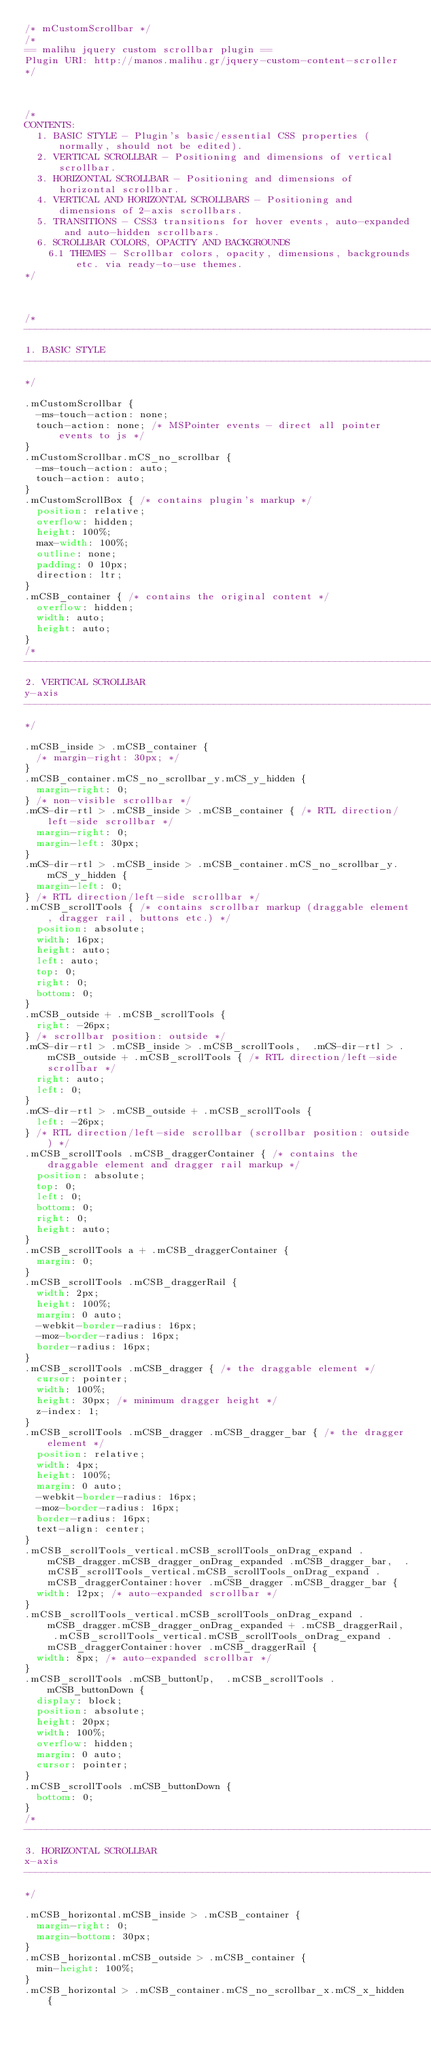Convert code to text. <code><loc_0><loc_0><loc_500><loc_500><_CSS_>/* mCustomScrollbar */
/*
== malihu jquery custom scrollbar plugin ==
Plugin URI: http://manos.malihu.gr/jquery-custom-content-scroller
*/



/*
CONTENTS: 
	1. BASIC STYLE - Plugin's basic/essential CSS properties (normally, should not be edited). 
	2. VERTICAL SCROLLBAR - Positioning and dimensions of vertical scrollbar. 
	3. HORIZONTAL SCROLLBAR - Positioning and dimensions of horizontal scrollbar.
	4. VERTICAL AND HORIZONTAL SCROLLBARS - Positioning and dimensions of 2-axis scrollbars. 
	5. TRANSITIONS - CSS3 transitions for hover events, auto-expanded and auto-hidden scrollbars. 
	6. SCROLLBAR COLORS, OPACITY AND BACKGROUNDS 
		6.1 THEMES - Scrollbar colors, opacity, dimensions, backgrounds etc. via ready-to-use themes.
*/



/* 
------------------------------------------------------------------------------------------------------------------------
1. BASIC STYLE  
------------------------------------------------------------------------------------------------------------------------
*/

.mCustomScrollbar {
	-ms-touch-action: none;
	touch-action: none; /* MSPointer events - direct all pointer events to js */
}
.mCustomScrollbar.mCS_no_scrollbar {
	-ms-touch-action: auto;
	touch-action: auto;
}
.mCustomScrollBox { /* contains plugin's markup */
	position: relative;
	overflow: hidden;
	height: 100%;
	max-width: 100%;
	outline: none;
	padding: 0 10px;
	direction: ltr;
}
.mCSB_container { /* contains the original content */
	overflow: hidden;
	width: auto;
	height: auto;
}
/* 
------------------------------------------------------------------------------------------------------------------------
2. VERTICAL SCROLLBAR 
y-axis
------------------------------------------------------------------------------------------------------------------------
*/

.mCSB_inside > .mCSB_container {
	/* margin-right: 30px; */
}
.mCSB_container.mCS_no_scrollbar_y.mCS_y_hidden {
	margin-right: 0;
} /* non-visible scrollbar */
.mCS-dir-rtl > .mCSB_inside > .mCSB_container { /* RTL direction/left-side scrollbar */
	margin-right: 0;
	margin-left: 30px;
}
.mCS-dir-rtl > .mCSB_inside > .mCSB_container.mCS_no_scrollbar_y.mCS_y_hidden {
	margin-left: 0;
} /* RTL direction/left-side scrollbar */
.mCSB_scrollTools { /* contains scrollbar markup (draggable element, dragger rail, buttons etc.) */
	position: absolute;
	width: 16px;
	height: auto;
	left: auto;
	top: 0;
	right: 0;
	bottom: 0;
}
.mCSB_outside + .mCSB_scrollTools {
	right: -26px;
} /* scrollbar position: outside */
.mCS-dir-rtl > .mCSB_inside > .mCSB_scrollTools,  .mCS-dir-rtl > .mCSB_outside + .mCSB_scrollTools { /* RTL direction/left-side scrollbar */
	right: auto;
	left: 0;
}
.mCS-dir-rtl > .mCSB_outside + .mCSB_scrollTools {
	left: -26px;
} /* RTL direction/left-side scrollbar (scrollbar position: outside) */
.mCSB_scrollTools .mCSB_draggerContainer { /* contains the draggable element and dragger rail markup */
	position: absolute;
	top: 0;
	left: 0;
	bottom: 0;
	right: 0;
	height: auto;
}
.mCSB_scrollTools a + .mCSB_draggerContainer {
	margin: 0;
}
.mCSB_scrollTools .mCSB_draggerRail {
	width: 2px;
	height: 100%;
	margin: 0 auto;
	-webkit-border-radius: 16px;
	-moz-border-radius: 16px;
	border-radius: 16px;
}
.mCSB_scrollTools .mCSB_dragger { /* the draggable element */
	cursor: pointer;
	width: 100%;
	height: 30px; /* minimum dragger height */
	z-index: 1;
}
.mCSB_scrollTools .mCSB_dragger .mCSB_dragger_bar { /* the dragger element */
	position: relative;
	width: 4px;
	height: 100%;
	margin: 0 auto;
	-webkit-border-radius: 16px;
	-moz-border-radius: 16px;
	border-radius: 16px;
	text-align: center;
}
.mCSB_scrollTools_vertical.mCSB_scrollTools_onDrag_expand .mCSB_dragger.mCSB_dragger_onDrag_expanded .mCSB_dragger_bar,  .mCSB_scrollTools_vertical.mCSB_scrollTools_onDrag_expand .mCSB_draggerContainer:hover .mCSB_dragger .mCSB_dragger_bar {
	width: 12px; /* auto-expanded scrollbar */
}
.mCSB_scrollTools_vertical.mCSB_scrollTools_onDrag_expand .mCSB_dragger.mCSB_dragger_onDrag_expanded + .mCSB_draggerRail,  .mCSB_scrollTools_vertical.mCSB_scrollTools_onDrag_expand .mCSB_draggerContainer:hover .mCSB_draggerRail {
	width: 8px; /* auto-expanded scrollbar */
}
.mCSB_scrollTools .mCSB_buttonUp,  .mCSB_scrollTools .mCSB_buttonDown {
	display: block;
	position: absolute;
	height: 20px;
	width: 100%;
	overflow: hidden;
	margin: 0 auto;
	cursor: pointer;
}
.mCSB_scrollTools .mCSB_buttonDown {
	bottom: 0;
}
/* 
------------------------------------------------------------------------------------------------------------------------
3. HORIZONTAL SCROLLBAR 
x-axis
------------------------------------------------------------------------------------------------------------------------
*/

.mCSB_horizontal.mCSB_inside > .mCSB_container {
	margin-right: 0;
	margin-bottom: 30px;
}
.mCSB_horizontal.mCSB_outside > .mCSB_container {
	min-height: 100%;
}
.mCSB_horizontal > .mCSB_container.mCS_no_scrollbar_x.mCS_x_hidden {</code> 